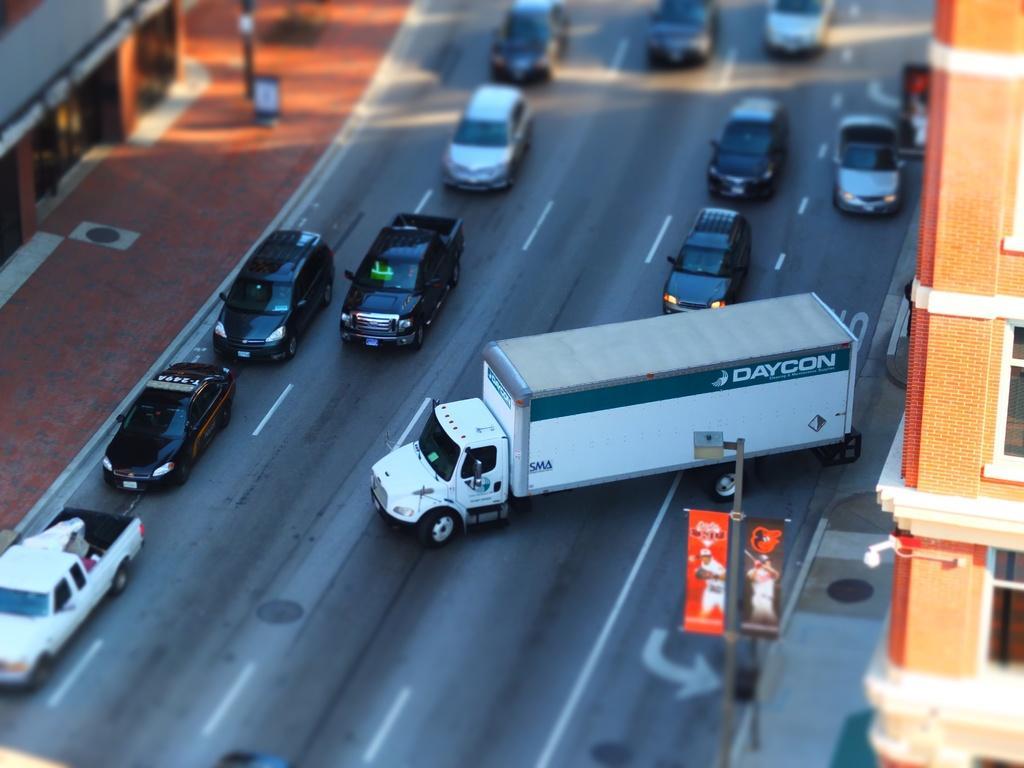Can you describe this image briefly? In this picture we can see cars and a truck on the road, banners, poles, footpath and in the background we can see buildings with windows. 